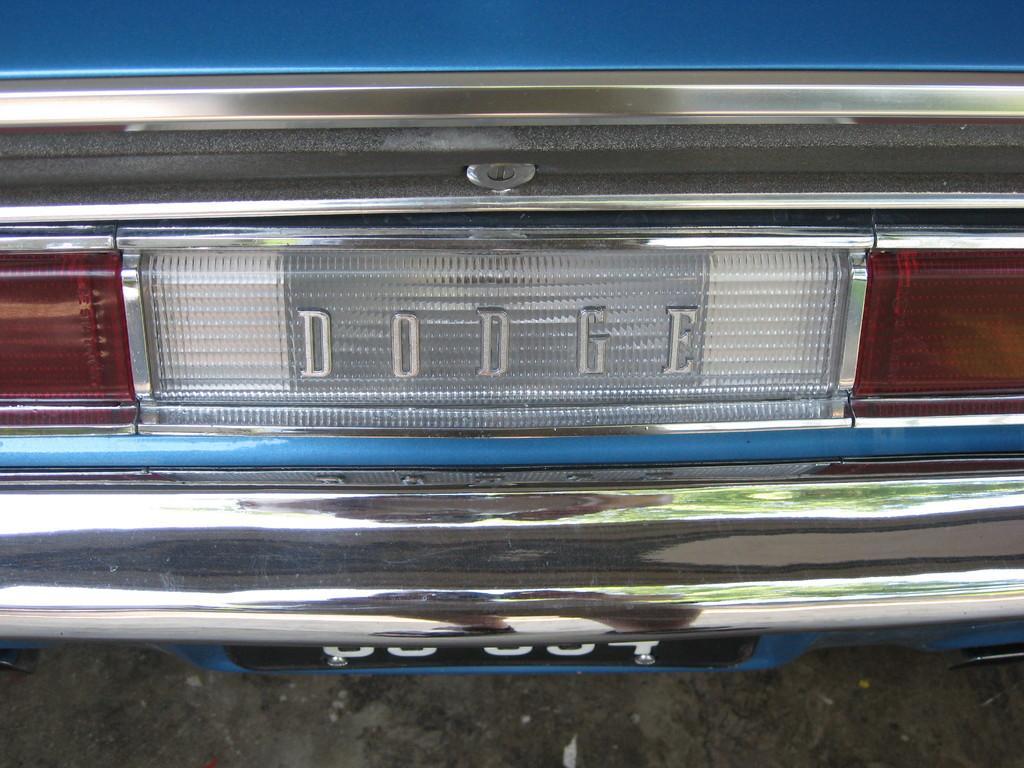How would you summarize this image in a sentence or two? This image is taken outdoors. At the bottom of the image there is a road. In the middle of the image a car is parked on the road. 